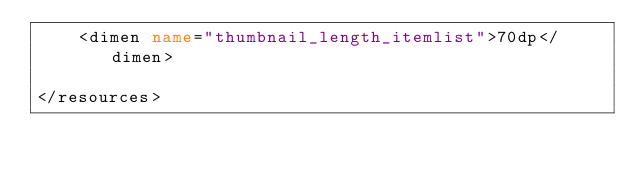<code> <loc_0><loc_0><loc_500><loc_500><_XML_>    <dimen name="thumbnail_length_itemlist">70dp</dimen>

</resources></code> 